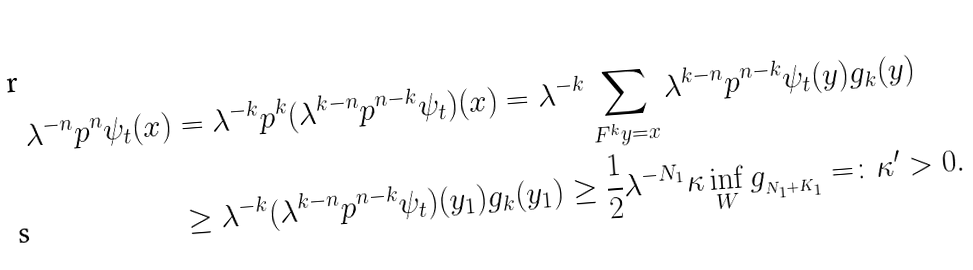Convert formula to latex. <formula><loc_0><loc_0><loc_500><loc_500>\lambda ^ { - n } \L p ^ { n } \psi _ { t } ( x ) & = \lambda ^ { - k } \L p ^ { k } ( \lambda ^ { k - n } \L p ^ { n - k } \psi _ { t } ) ( x ) = \lambda ^ { - k } \sum _ { F ^ { k } y = x } \lambda ^ { k - n } \L p ^ { n - k } \psi _ { t } ( y ) g _ { k } ( y ) \\ & \geq \lambda ^ { - k } ( \lambda ^ { k - n } \L p ^ { n - k } \psi _ { t } ) ( y _ { 1 } ) g _ { k } ( y _ { 1 } ) \geq { \frac { 1 } { 2 } } \lambda ^ { - N _ { 1 } } \kappa \inf _ { W } g _ { _ { N _ { 1 } + K _ { 1 } } } = \colon \kappa ^ { \prime } > 0 .</formula> 